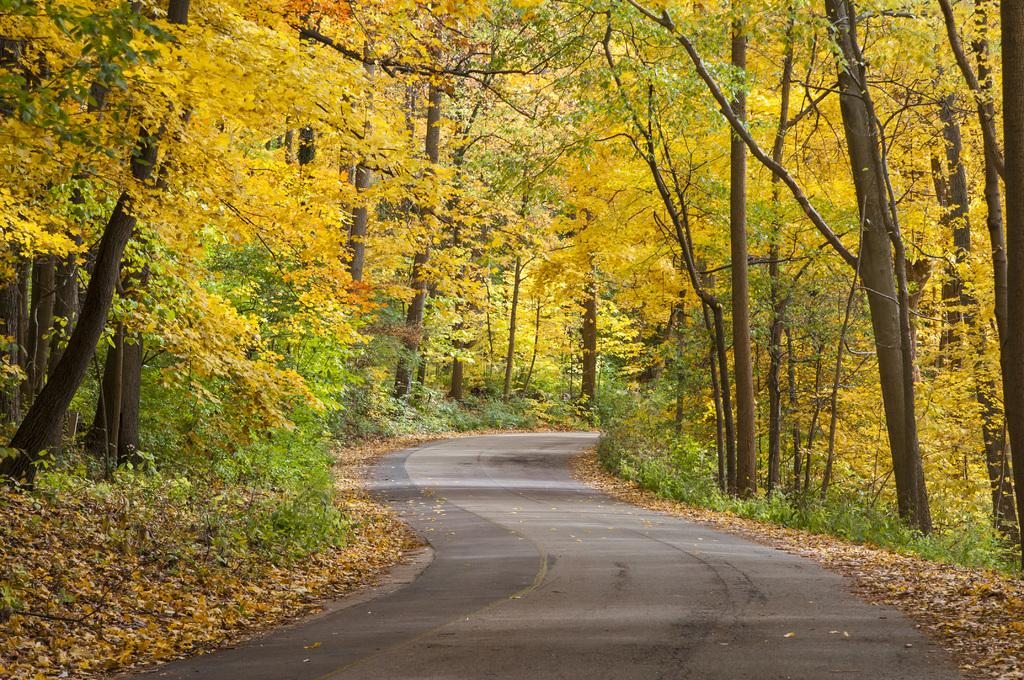What is the main feature in the middle of the image? There is a road in the middle of the image. What can be seen on both sides of the road? There are trees on either side of the road. What is present on the ground in the image? Leaves are present on the ground. How many jokes can be seen being told by the expert in the image? There is no expert or joke present in the image. What day of the week is depicted in the image? The day of the week is not mentioned or depicted in the image. 